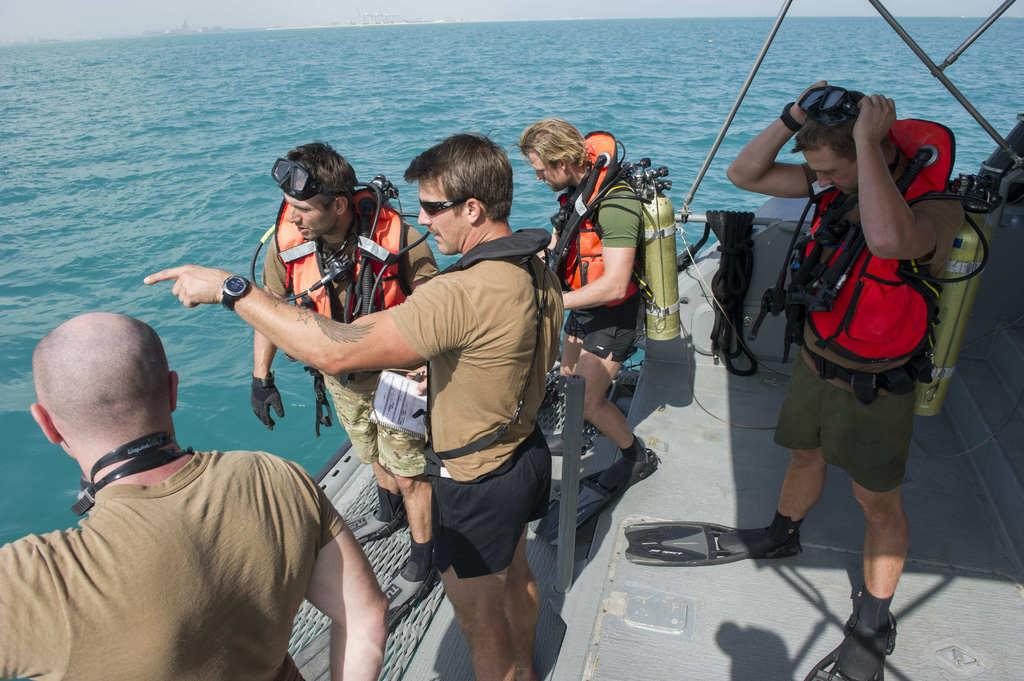What are the people in the image doing? The people in the image are standing on a boat. What are the cylinders on the backs of some people used for? The cylinders on the backs of some people are likely used for scuba diving or other underwater activities. What can be seen in the background of the image? Water and the sky are visible in the background of the image. How many hydrants are visible in the image? There are no hydrants present in the image. What type of connection is being made between the people on the boat? There is no indication of any connections being made between the people in the image. 